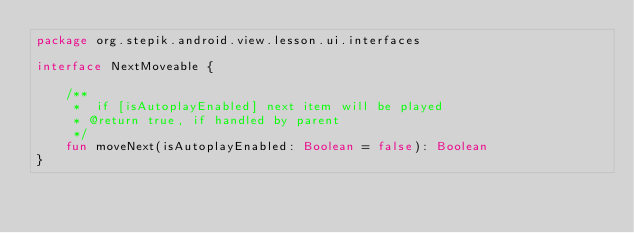Convert code to text. <code><loc_0><loc_0><loc_500><loc_500><_Kotlin_>package org.stepik.android.view.lesson.ui.interfaces

interface NextMoveable {

    /**
     *  if [isAutoplayEnabled] next item will be played
     * @return true, if handled by parent
     */
    fun moveNext(isAutoplayEnabled: Boolean = false): Boolean
}
</code> 